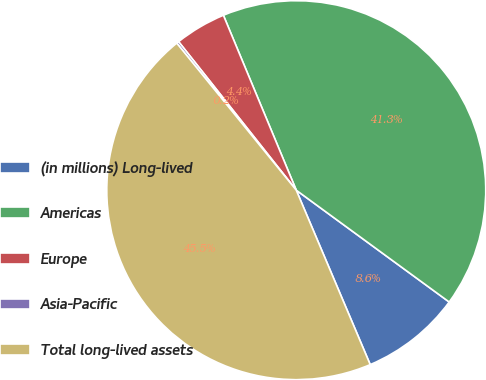Convert chart. <chart><loc_0><loc_0><loc_500><loc_500><pie_chart><fcel>(in millions) Long-lived<fcel>Americas<fcel>Europe<fcel>Asia-Pacific<fcel>Total long-lived assets<nl><fcel>8.57%<fcel>41.33%<fcel>4.38%<fcel>0.2%<fcel>45.52%<nl></chart> 